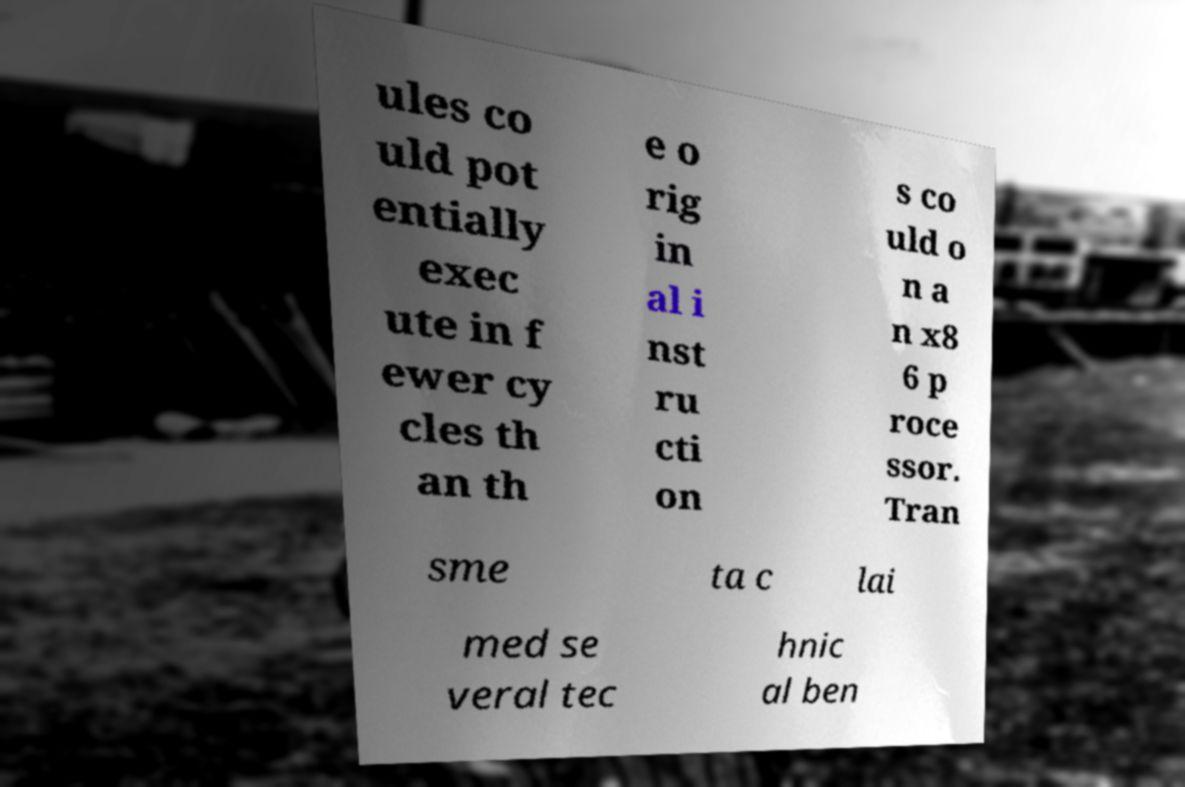I need the written content from this picture converted into text. Can you do that? ules co uld pot entially exec ute in f ewer cy cles th an th e o rig in al i nst ru cti on s co uld o n a n x8 6 p roce ssor. Tran sme ta c lai med se veral tec hnic al ben 